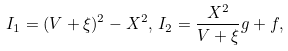Convert formula to latex. <formula><loc_0><loc_0><loc_500><loc_500>I _ { 1 } = ( V + \xi ) ^ { 2 } - X ^ { 2 } , \, I _ { 2 } = \frac { X ^ { 2 } } { V + \xi } g + f ,</formula> 